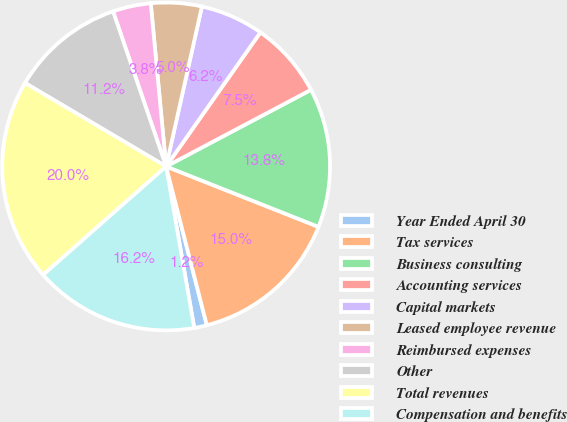<chart> <loc_0><loc_0><loc_500><loc_500><pie_chart><fcel>Year Ended April 30<fcel>Tax services<fcel>Business consulting<fcel>Accounting services<fcel>Capital markets<fcel>Leased employee revenue<fcel>Reimbursed expenses<fcel>Other<fcel>Total revenues<fcel>Compensation and benefits<nl><fcel>1.25%<fcel>15.0%<fcel>13.75%<fcel>7.5%<fcel>6.25%<fcel>5.0%<fcel>3.75%<fcel>11.25%<fcel>20.0%<fcel>16.25%<nl></chart> 